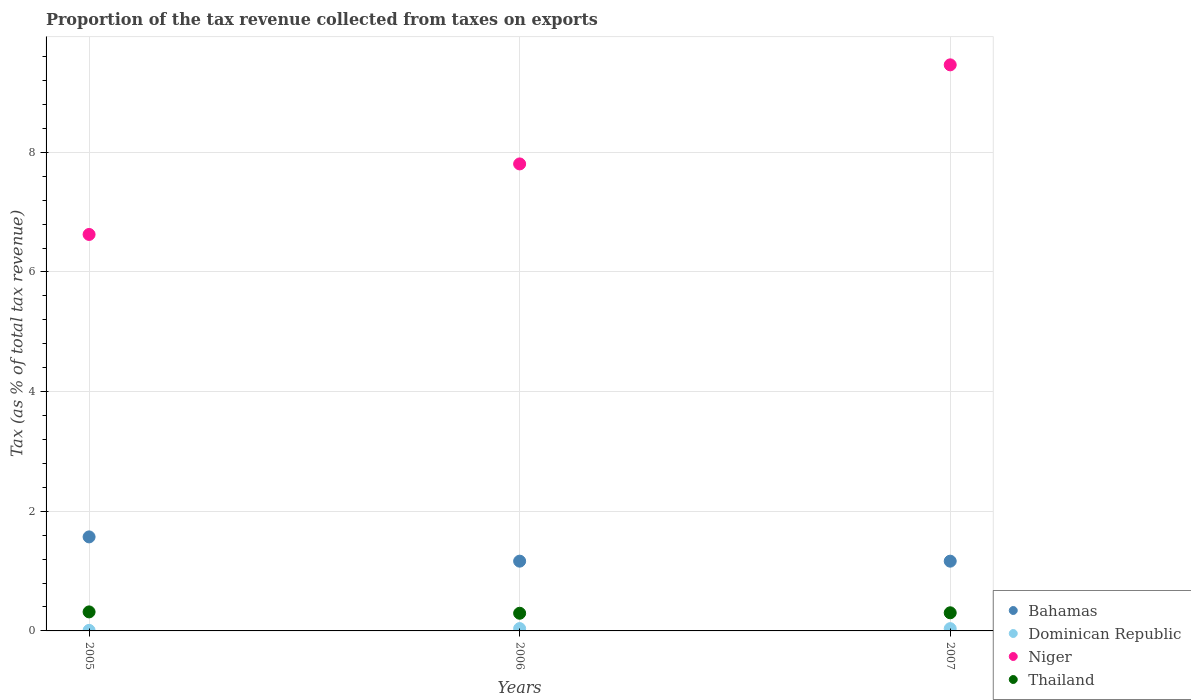Is the number of dotlines equal to the number of legend labels?
Offer a terse response. Yes. What is the proportion of the tax revenue collected in Niger in 2006?
Offer a very short reply. 7.81. Across all years, what is the maximum proportion of the tax revenue collected in Niger?
Provide a short and direct response. 9.46. Across all years, what is the minimum proportion of the tax revenue collected in Bahamas?
Keep it short and to the point. 1.17. In which year was the proportion of the tax revenue collected in Dominican Republic minimum?
Your response must be concise. 2005. What is the total proportion of the tax revenue collected in Niger in the graph?
Offer a terse response. 23.89. What is the difference between the proportion of the tax revenue collected in Bahamas in 2006 and that in 2007?
Keep it short and to the point. 0. What is the difference between the proportion of the tax revenue collected in Thailand in 2005 and the proportion of the tax revenue collected in Dominican Republic in 2007?
Provide a succinct answer. 0.28. What is the average proportion of the tax revenue collected in Thailand per year?
Provide a short and direct response. 0.31. In the year 2007, what is the difference between the proportion of the tax revenue collected in Thailand and proportion of the tax revenue collected in Bahamas?
Your answer should be very brief. -0.86. What is the ratio of the proportion of the tax revenue collected in Niger in 2006 to that in 2007?
Give a very brief answer. 0.82. What is the difference between the highest and the second highest proportion of the tax revenue collected in Niger?
Provide a succinct answer. 1.66. What is the difference between the highest and the lowest proportion of the tax revenue collected in Dominican Republic?
Make the answer very short. 0.03. Is the sum of the proportion of the tax revenue collected in Niger in 2005 and 2006 greater than the maximum proportion of the tax revenue collected in Dominican Republic across all years?
Ensure brevity in your answer.  Yes. Is it the case that in every year, the sum of the proportion of the tax revenue collected in Dominican Republic and proportion of the tax revenue collected in Niger  is greater than the sum of proportion of the tax revenue collected in Bahamas and proportion of the tax revenue collected in Thailand?
Your answer should be compact. Yes. Is it the case that in every year, the sum of the proportion of the tax revenue collected in Thailand and proportion of the tax revenue collected in Bahamas  is greater than the proportion of the tax revenue collected in Dominican Republic?
Make the answer very short. Yes. How many dotlines are there?
Offer a very short reply. 4. How many years are there in the graph?
Ensure brevity in your answer.  3. What is the title of the graph?
Your answer should be compact. Proportion of the tax revenue collected from taxes on exports. What is the label or title of the Y-axis?
Your answer should be compact. Tax (as % of total tax revenue). What is the Tax (as % of total tax revenue) of Bahamas in 2005?
Provide a short and direct response. 1.57. What is the Tax (as % of total tax revenue) in Dominican Republic in 2005?
Make the answer very short. 0.01. What is the Tax (as % of total tax revenue) in Niger in 2005?
Offer a very short reply. 6.63. What is the Tax (as % of total tax revenue) in Thailand in 2005?
Make the answer very short. 0.32. What is the Tax (as % of total tax revenue) in Bahamas in 2006?
Give a very brief answer. 1.17. What is the Tax (as % of total tax revenue) of Dominican Republic in 2006?
Your answer should be compact. 0.04. What is the Tax (as % of total tax revenue) in Niger in 2006?
Provide a succinct answer. 7.81. What is the Tax (as % of total tax revenue) in Thailand in 2006?
Provide a short and direct response. 0.3. What is the Tax (as % of total tax revenue) in Bahamas in 2007?
Your answer should be very brief. 1.17. What is the Tax (as % of total tax revenue) in Dominican Republic in 2007?
Offer a terse response. 0.04. What is the Tax (as % of total tax revenue) of Niger in 2007?
Offer a terse response. 9.46. What is the Tax (as % of total tax revenue) in Thailand in 2007?
Offer a very short reply. 0.3. Across all years, what is the maximum Tax (as % of total tax revenue) of Bahamas?
Your answer should be compact. 1.57. Across all years, what is the maximum Tax (as % of total tax revenue) of Dominican Republic?
Your response must be concise. 0.04. Across all years, what is the maximum Tax (as % of total tax revenue) in Niger?
Offer a terse response. 9.46. Across all years, what is the maximum Tax (as % of total tax revenue) in Thailand?
Your answer should be very brief. 0.32. Across all years, what is the minimum Tax (as % of total tax revenue) in Bahamas?
Keep it short and to the point. 1.17. Across all years, what is the minimum Tax (as % of total tax revenue) of Dominican Republic?
Your answer should be compact. 0.01. Across all years, what is the minimum Tax (as % of total tax revenue) of Niger?
Provide a short and direct response. 6.63. Across all years, what is the minimum Tax (as % of total tax revenue) in Thailand?
Keep it short and to the point. 0.3. What is the total Tax (as % of total tax revenue) in Bahamas in the graph?
Offer a very short reply. 3.9. What is the total Tax (as % of total tax revenue) in Dominican Republic in the graph?
Make the answer very short. 0.09. What is the total Tax (as % of total tax revenue) of Niger in the graph?
Your answer should be very brief. 23.89. What is the total Tax (as % of total tax revenue) in Thailand in the graph?
Offer a very short reply. 0.92. What is the difference between the Tax (as % of total tax revenue) of Bahamas in 2005 and that in 2006?
Your answer should be very brief. 0.41. What is the difference between the Tax (as % of total tax revenue) of Dominican Republic in 2005 and that in 2006?
Your answer should be compact. -0.03. What is the difference between the Tax (as % of total tax revenue) in Niger in 2005 and that in 2006?
Make the answer very short. -1.18. What is the difference between the Tax (as % of total tax revenue) of Thailand in 2005 and that in 2006?
Make the answer very short. 0.02. What is the difference between the Tax (as % of total tax revenue) in Bahamas in 2005 and that in 2007?
Provide a short and direct response. 0.41. What is the difference between the Tax (as % of total tax revenue) of Dominican Republic in 2005 and that in 2007?
Ensure brevity in your answer.  -0.03. What is the difference between the Tax (as % of total tax revenue) of Niger in 2005 and that in 2007?
Ensure brevity in your answer.  -2.83. What is the difference between the Tax (as % of total tax revenue) in Thailand in 2005 and that in 2007?
Your response must be concise. 0.01. What is the difference between the Tax (as % of total tax revenue) of Bahamas in 2006 and that in 2007?
Your response must be concise. 0. What is the difference between the Tax (as % of total tax revenue) of Dominican Republic in 2006 and that in 2007?
Make the answer very short. 0. What is the difference between the Tax (as % of total tax revenue) in Niger in 2006 and that in 2007?
Provide a short and direct response. -1.66. What is the difference between the Tax (as % of total tax revenue) of Thailand in 2006 and that in 2007?
Make the answer very short. -0.01. What is the difference between the Tax (as % of total tax revenue) of Bahamas in 2005 and the Tax (as % of total tax revenue) of Dominican Republic in 2006?
Make the answer very short. 1.53. What is the difference between the Tax (as % of total tax revenue) of Bahamas in 2005 and the Tax (as % of total tax revenue) of Niger in 2006?
Ensure brevity in your answer.  -6.23. What is the difference between the Tax (as % of total tax revenue) in Bahamas in 2005 and the Tax (as % of total tax revenue) in Thailand in 2006?
Keep it short and to the point. 1.28. What is the difference between the Tax (as % of total tax revenue) in Dominican Republic in 2005 and the Tax (as % of total tax revenue) in Niger in 2006?
Provide a short and direct response. -7.8. What is the difference between the Tax (as % of total tax revenue) in Dominican Republic in 2005 and the Tax (as % of total tax revenue) in Thailand in 2006?
Give a very brief answer. -0.29. What is the difference between the Tax (as % of total tax revenue) in Niger in 2005 and the Tax (as % of total tax revenue) in Thailand in 2006?
Your response must be concise. 6.33. What is the difference between the Tax (as % of total tax revenue) in Bahamas in 2005 and the Tax (as % of total tax revenue) in Dominican Republic in 2007?
Make the answer very short. 1.53. What is the difference between the Tax (as % of total tax revenue) in Bahamas in 2005 and the Tax (as % of total tax revenue) in Niger in 2007?
Provide a short and direct response. -7.89. What is the difference between the Tax (as % of total tax revenue) of Bahamas in 2005 and the Tax (as % of total tax revenue) of Thailand in 2007?
Provide a succinct answer. 1.27. What is the difference between the Tax (as % of total tax revenue) of Dominican Republic in 2005 and the Tax (as % of total tax revenue) of Niger in 2007?
Give a very brief answer. -9.45. What is the difference between the Tax (as % of total tax revenue) in Dominican Republic in 2005 and the Tax (as % of total tax revenue) in Thailand in 2007?
Your response must be concise. -0.29. What is the difference between the Tax (as % of total tax revenue) in Niger in 2005 and the Tax (as % of total tax revenue) in Thailand in 2007?
Your response must be concise. 6.32. What is the difference between the Tax (as % of total tax revenue) of Bahamas in 2006 and the Tax (as % of total tax revenue) of Dominican Republic in 2007?
Give a very brief answer. 1.13. What is the difference between the Tax (as % of total tax revenue) in Bahamas in 2006 and the Tax (as % of total tax revenue) in Niger in 2007?
Offer a very short reply. -8.3. What is the difference between the Tax (as % of total tax revenue) in Bahamas in 2006 and the Tax (as % of total tax revenue) in Thailand in 2007?
Your answer should be compact. 0.86. What is the difference between the Tax (as % of total tax revenue) of Dominican Republic in 2006 and the Tax (as % of total tax revenue) of Niger in 2007?
Your answer should be compact. -9.42. What is the difference between the Tax (as % of total tax revenue) in Dominican Republic in 2006 and the Tax (as % of total tax revenue) in Thailand in 2007?
Make the answer very short. -0.26. What is the difference between the Tax (as % of total tax revenue) in Niger in 2006 and the Tax (as % of total tax revenue) in Thailand in 2007?
Ensure brevity in your answer.  7.5. What is the average Tax (as % of total tax revenue) of Bahamas per year?
Offer a terse response. 1.3. What is the average Tax (as % of total tax revenue) in Dominican Republic per year?
Your answer should be very brief. 0.03. What is the average Tax (as % of total tax revenue) of Niger per year?
Give a very brief answer. 7.96. What is the average Tax (as % of total tax revenue) in Thailand per year?
Give a very brief answer. 0.31. In the year 2005, what is the difference between the Tax (as % of total tax revenue) in Bahamas and Tax (as % of total tax revenue) in Dominican Republic?
Your response must be concise. 1.56. In the year 2005, what is the difference between the Tax (as % of total tax revenue) of Bahamas and Tax (as % of total tax revenue) of Niger?
Keep it short and to the point. -5.06. In the year 2005, what is the difference between the Tax (as % of total tax revenue) of Bahamas and Tax (as % of total tax revenue) of Thailand?
Your response must be concise. 1.25. In the year 2005, what is the difference between the Tax (as % of total tax revenue) of Dominican Republic and Tax (as % of total tax revenue) of Niger?
Your answer should be compact. -6.62. In the year 2005, what is the difference between the Tax (as % of total tax revenue) in Dominican Republic and Tax (as % of total tax revenue) in Thailand?
Give a very brief answer. -0.31. In the year 2005, what is the difference between the Tax (as % of total tax revenue) in Niger and Tax (as % of total tax revenue) in Thailand?
Your response must be concise. 6.31. In the year 2006, what is the difference between the Tax (as % of total tax revenue) of Bahamas and Tax (as % of total tax revenue) of Dominican Republic?
Ensure brevity in your answer.  1.13. In the year 2006, what is the difference between the Tax (as % of total tax revenue) of Bahamas and Tax (as % of total tax revenue) of Niger?
Offer a terse response. -6.64. In the year 2006, what is the difference between the Tax (as % of total tax revenue) in Bahamas and Tax (as % of total tax revenue) in Thailand?
Provide a succinct answer. 0.87. In the year 2006, what is the difference between the Tax (as % of total tax revenue) in Dominican Republic and Tax (as % of total tax revenue) in Niger?
Ensure brevity in your answer.  -7.77. In the year 2006, what is the difference between the Tax (as % of total tax revenue) of Dominican Republic and Tax (as % of total tax revenue) of Thailand?
Keep it short and to the point. -0.26. In the year 2006, what is the difference between the Tax (as % of total tax revenue) in Niger and Tax (as % of total tax revenue) in Thailand?
Give a very brief answer. 7.51. In the year 2007, what is the difference between the Tax (as % of total tax revenue) of Bahamas and Tax (as % of total tax revenue) of Dominican Republic?
Provide a short and direct response. 1.13. In the year 2007, what is the difference between the Tax (as % of total tax revenue) of Bahamas and Tax (as % of total tax revenue) of Niger?
Your answer should be compact. -8.3. In the year 2007, what is the difference between the Tax (as % of total tax revenue) of Bahamas and Tax (as % of total tax revenue) of Thailand?
Offer a very short reply. 0.86. In the year 2007, what is the difference between the Tax (as % of total tax revenue) in Dominican Republic and Tax (as % of total tax revenue) in Niger?
Your answer should be very brief. -9.42. In the year 2007, what is the difference between the Tax (as % of total tax revenue) in Dominican Republic and Tax (as % of total tax revenue) in Thailand?
Ensure brevity in your answer.  -0.27. In the year 2007, what is the difference between the Tax (as % of total tax revenue) in Niger and Tax (as % of total tax revenue) in Thailand?
Provide a short and direct response. 9.16. What is the ratio of the Tax (as % of total tax revenue) of Bahamas in 2005 to that in 2006?
Keep it short and to the point. 1.35. What is the ratio of the Tax (as % of total tax revenue) in Dominican Republic in 2005 to that in 2006?
Your answer should be compact. 0.23. What is the ratio of the Tax (as % of total tax revenue) in Niger in 2005 to that in 2006?
Your response must be concise. 0.85. What is the ratio of the Tax (as % of total tax revenue) in Thailand in 2005 to that in 2006?
Provide a succinct answer. 1.08. What is the ratio of the Tax (as % of total tax revenue) in Bahamas in 2005 to that in 2007?
Keep it short and to the point. 1.35. What is the ratio of the Tax (as % of total tax revenue) in Dominican Republic in 2005 to that in 2007?
Your response must be concise. 0.24. What is the ratio of the Tax (as % of total tax revenue) in Niger in 2005 to that in 2007?
Your answer should be compact. 0.7. What is the ratio of the Tax (as % of total tax revenue) in Thailand in 2005 to that in 2007?
Provide a succinct answer. 1.05. What is the ratio of the Tax (as % of total tax revenue) in Dominican Republic in 2006 to that in 2007?
Make the answer very short. 1.03. What is the ratio of the Tax (as % of total tax revenue) in Niger in 2006 to that in 2007?
Provide a succinct answer. 0.82. What is the ratio of the Tax (as % of total tax revenue) of Thailand in 2006 to that in 2007?
Keep it short and to the point. 0.97. What is the difference between the highest and the second highest Tax (as % of total tax revenue) in Bahamas?
Your answer should be compact. 0.41. What is the difference between the highest and the second highest Tax (as % of total tax revenue) of Dominican Republic?
Give a very brief answer. 0. What is the difference between the highest and the second highest Tax (as % of total tax revenue) in Niger?
Offer a very short reply. 1.66. What is the difference between the highest and the second highest Tax (as % of total tax revenue) in Thailand?
Your answer should be compact. 0.01. What is the difference between the highest and the lowest Tax (as % of total tax revenue) of Bahamas?
Provide a succinct answer. 0.41. What is the difference between the highest and the lowest Tax (as % of total tax revenue) in Dominican Republic?
Provide a short and direct response. 0.03. What is the difference between the highest and the lowest Tax (as % of total tax revenue) of Niger?
Provide a short and direct response. 2.83. What is the difference between the highest and the lowest Tax (as % of total tax revenue) of Thailand?
Keep it short and to the point. 0.02. 